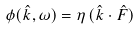Convert formula to latex. <formula><loc_0><loc_0><loc_500><loc_500>\phi ( \hat { k } , \omega ) = \eta \, ( \hat { k } \cdot \hat { F } )</formula> 